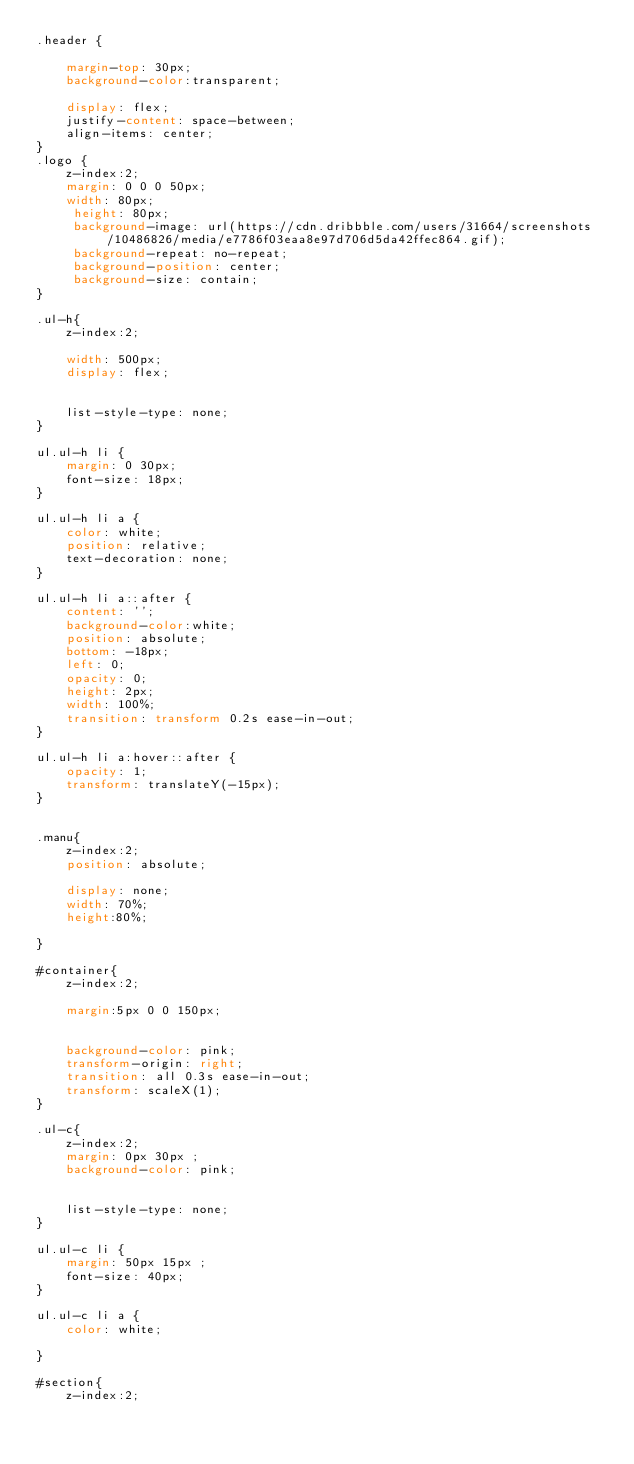<code> <loc_0><loc_0><loc_500><loc_500><_CSS_>.header {
	
	margin-top: 30px;
	background-color:transparent;
	
	display: flex;
	justify-content: space-between;
	align-items: center;
}
.logo {
	z-index:2;
	margin: 0 0 0 50px;
    width: 80px;
	 height: 80px;
	 background-image: url(https://cdn.dribbble.com/users/31664/screenshots/10486826/media/e7786f03eaa8e97d706d5da42ffec864.gif);
	 background-repeat: no-repeat;
	 background-position: center;
	 background-size: contain;
}

.ul-h{
	z-index:2;
	
    width: 500px;
	display: flex;
	
	
	list-style-type: none;
}

ul.ul-h li {
	margin: 0 30px;
	font-size: 18px;
}

ul.ul-h li a {
	color: white;
	position: relative;
	text-decoration: none;
}

ul.ul-h li a::after {
	content: '';
	background-color:white;
	position: absolute;
	bottom: -18px;
	left: 0;
	opacity: 0;
	height: 2px;
	width: 100%;
	transition: transform 0.2s ease-in-out;
}

ul.ul-h li a:hover::after {
	opacity: 1;
	transform: translateY(-15px);
}


.manu{
	z-index:2;
	position: absolute;
	
	display: none;
	width: 70%;
	height:80%;
	
}

#container{
	z-index:2;
	
	margin:5px 0 0 150px;
	
	
	background-color: pink;
	transform-origin: right;
	transition: all 0.3s ease-in-out;
	transform: scaleX(1);
}

.ul-c{
	z-index:2;
	margin: 0px 30px ;
	background-color: pink;
	
	
	list-style-type: none;
}

ul.ul-c li {
	margin: 50px 15px ;
	font-size: 40px;
}

ul.ul-c li a {
	color: white;
	
}

#section{
	z-index:2;</code> 